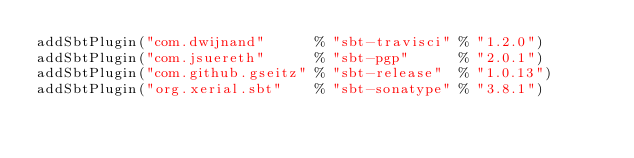Convert code to text. <code><loc_0><loc_0><loc_500><loc_500><_Scala_>addSbtPlugin("com.dwijnand"      % "sbt-travisci" % "1.2.0")
addSbtPlugin("com.jsuereth"      % "sbt-pgp"      % "2.0.1")
addSbtPlugin("com.github.gseitz" % "sbt-release"  % "1.0.13")
addSbtPlugin("org.xerial.sbt"    % "sbt-sonatype" % "3.8.1")
</code> 